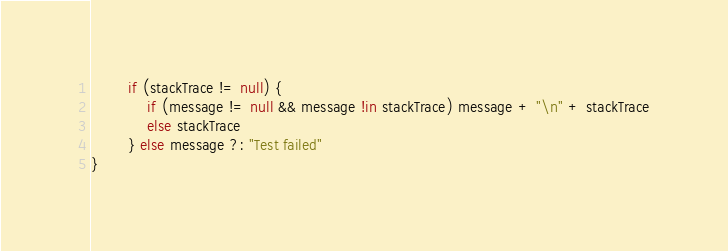Convert code to text. <code><loc_0><loc_0><loc_500><loc_500><_Kotlin_>        if (stackTrace != null) {
            if (message != null && message !in stackTrace) message + "\n" + stackTrace
            else stackTrace
        } else message ?: "Test failed"
}</code> 